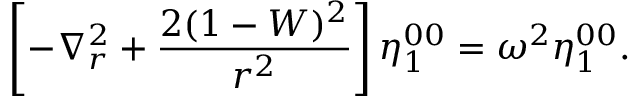Convert formula to latex. <formula><loc_0><loc_0><loc_500><loc_500>\left [ - \nabla _ { r } ^ { 2 } + \frac { 2 ( 1 - W ) ^ { 2 } } { r ^ { 2 } } \right ] \eta _ { 1 } ^ { 0 0 } = \omega ^ { 2 } \eta _ { 1 } ^ { 0 0 } .</formula> 